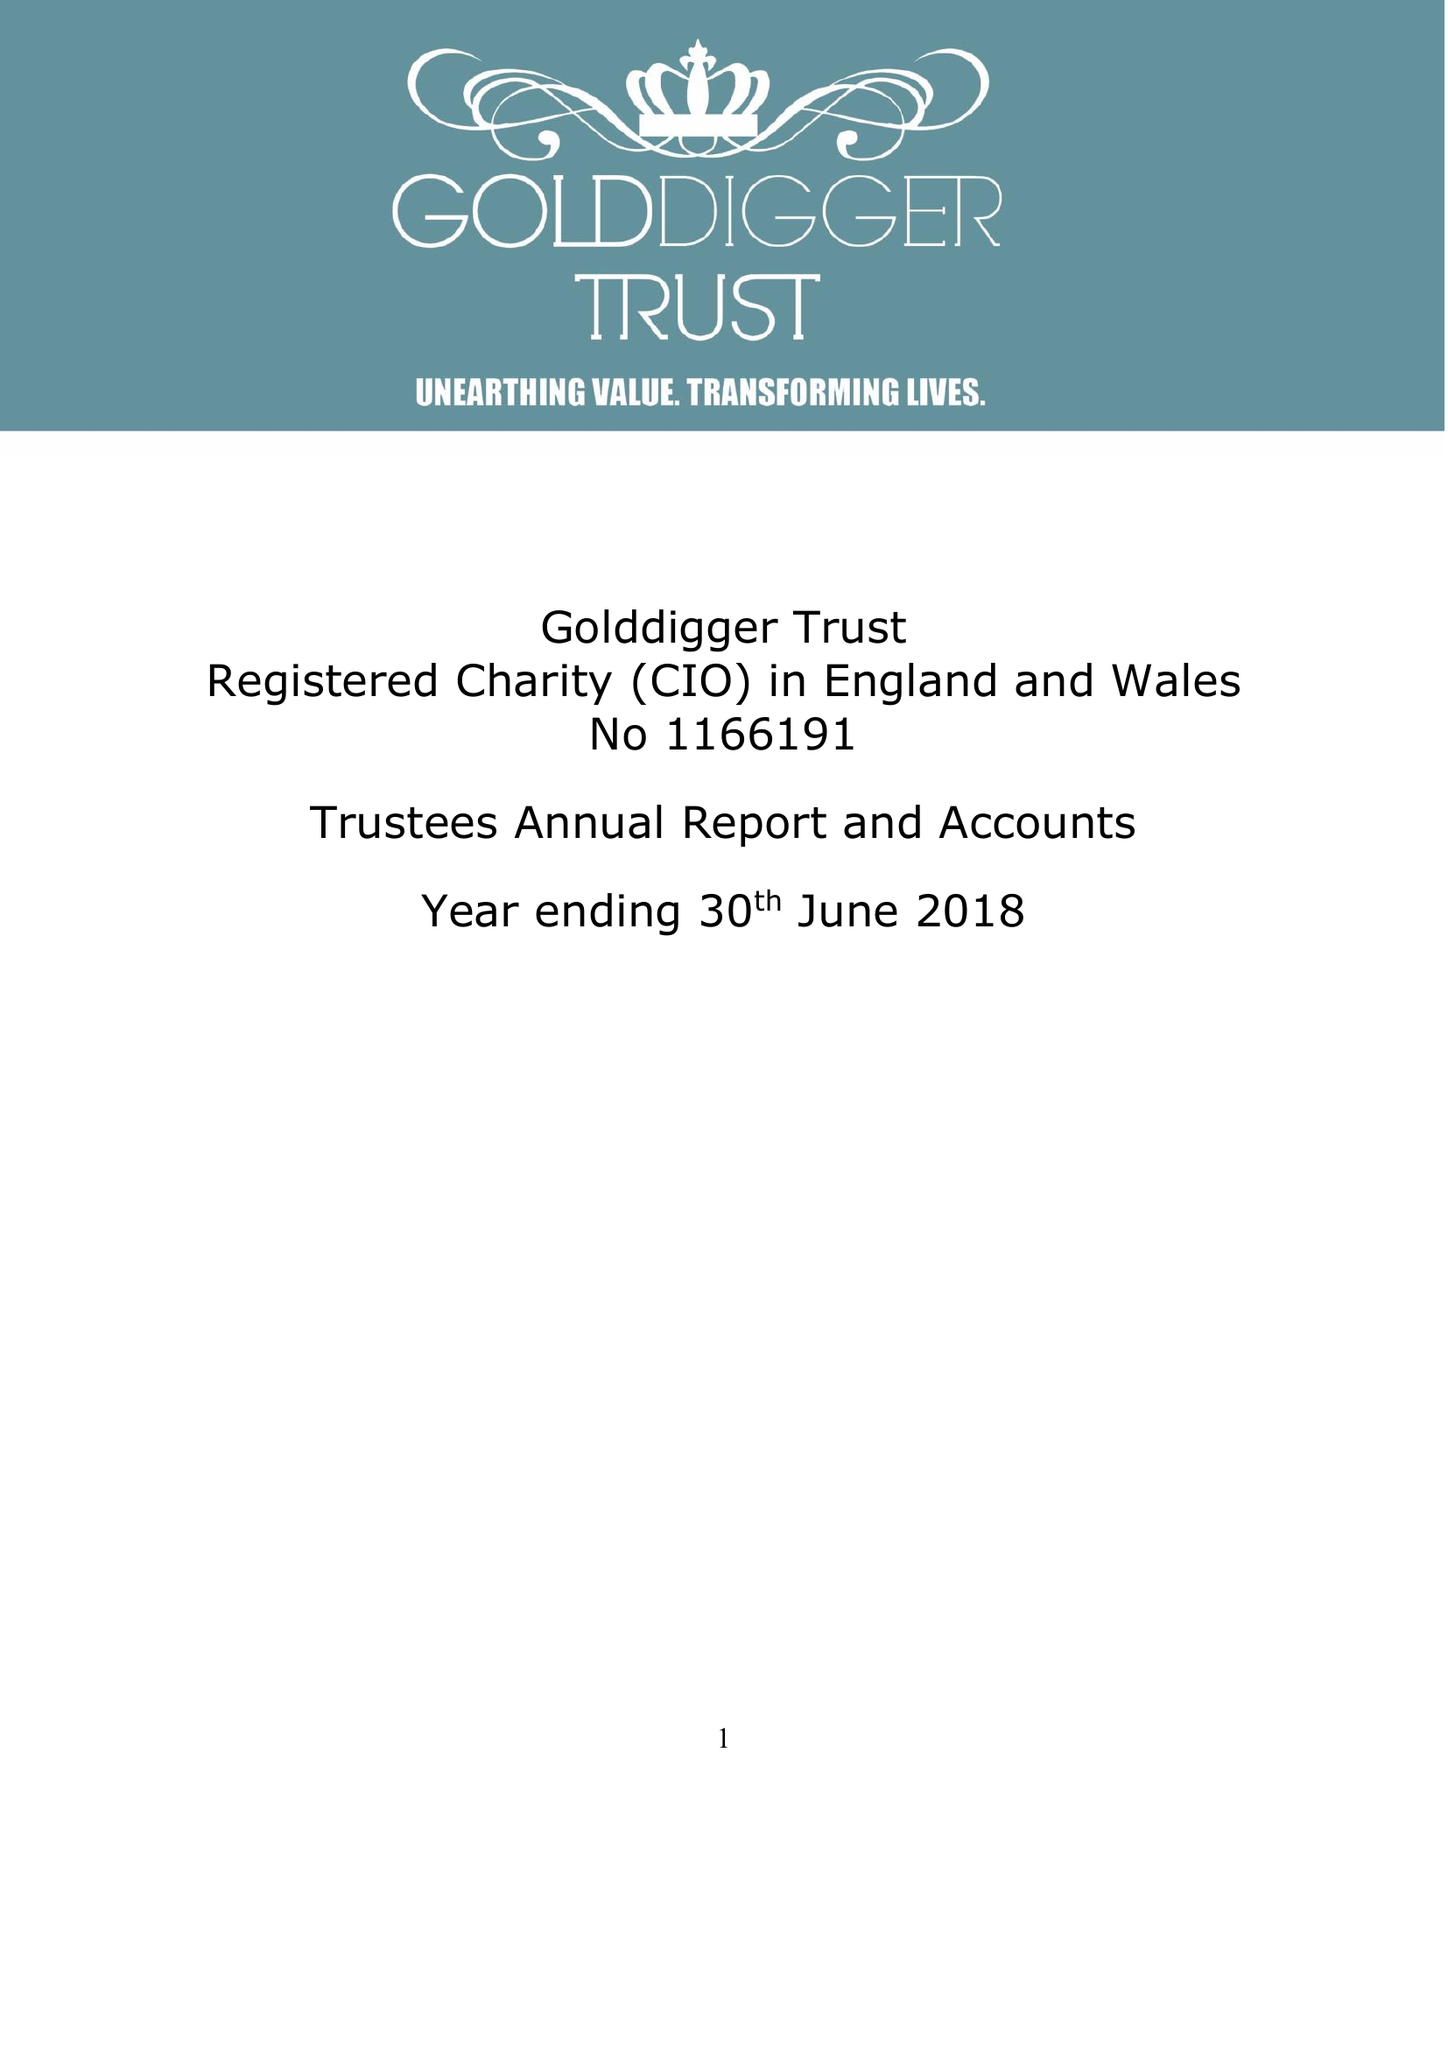What is the value for the income_annually_in_british_pounds?
Answer the question using a single word or phrase. 164245.00 